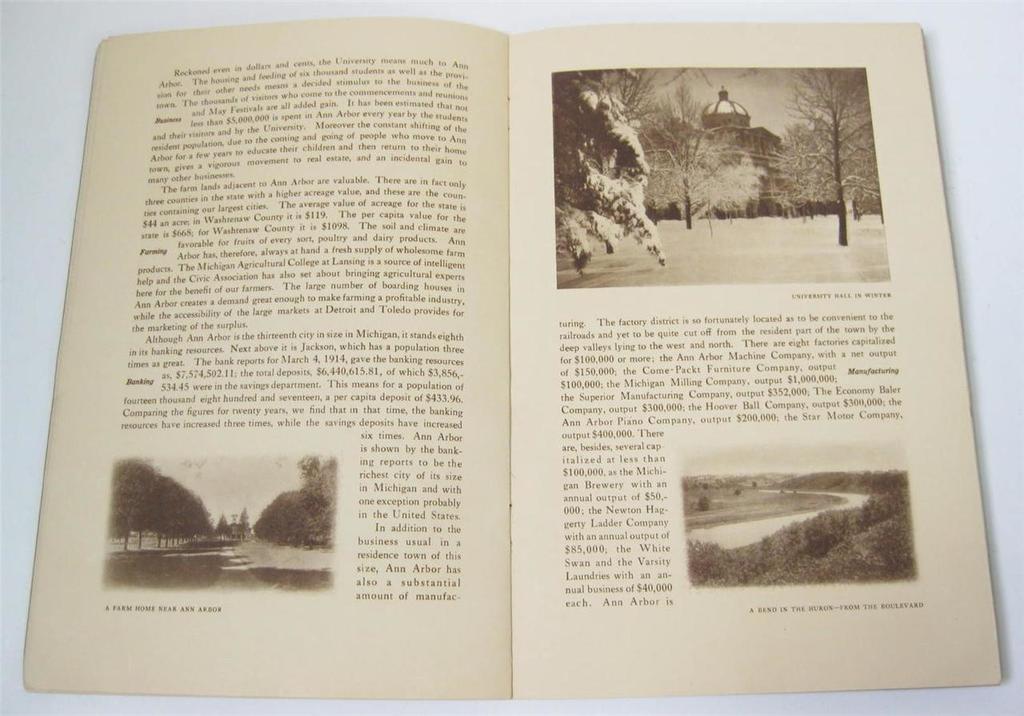Can you describe this image briefly? There is a book on a platform. Here we can see pictures of trees, building, and plants. There is text written on it. 